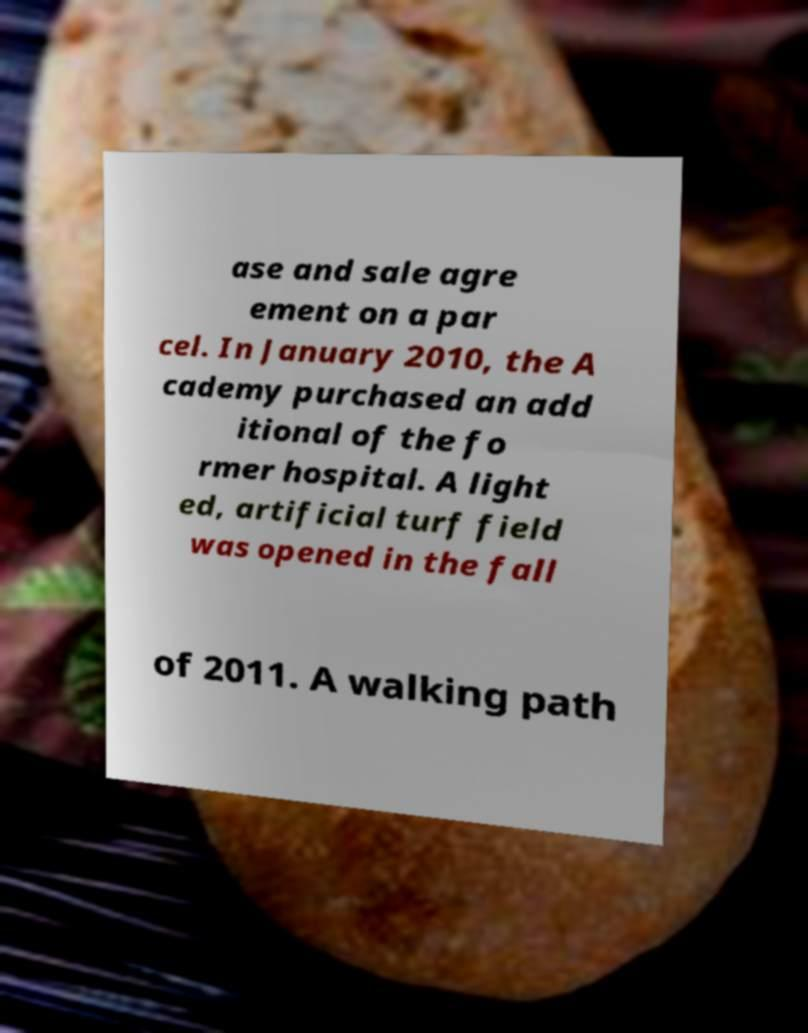For documentation purposes, I need the text within this image transcribed. Could you provide that? ase and sale agre ement on a par cel. In January 2010, the A cademy purchased an add itional of the fo rmer hospital. A light ed, artificial turf field was opened in the fall of 2011. A walking path 